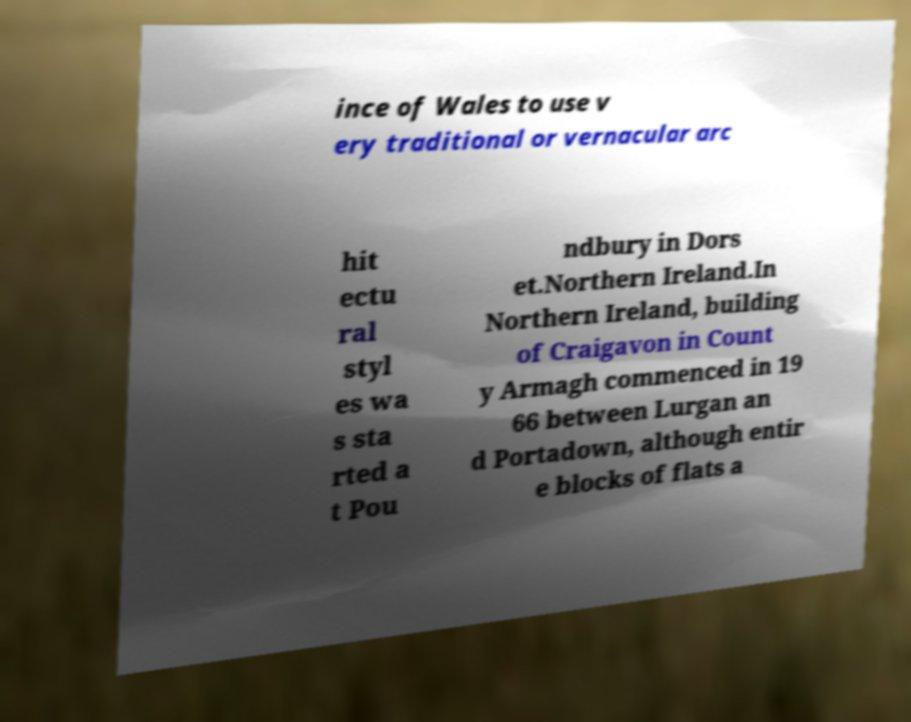Could you assist in decoding the text presented in this image and type it out clearly? ince of Wales to use v ery traditional or vernacular arc hit ectu ral styl es wa s sta rted a t Pou ndbury in Dors et.Northern Ireland.In Northern Ireland, building of Craigavon in Count y Armagh commenced in 19 66 between Lurgan an d Portadown, although entir e blocks of flats a 